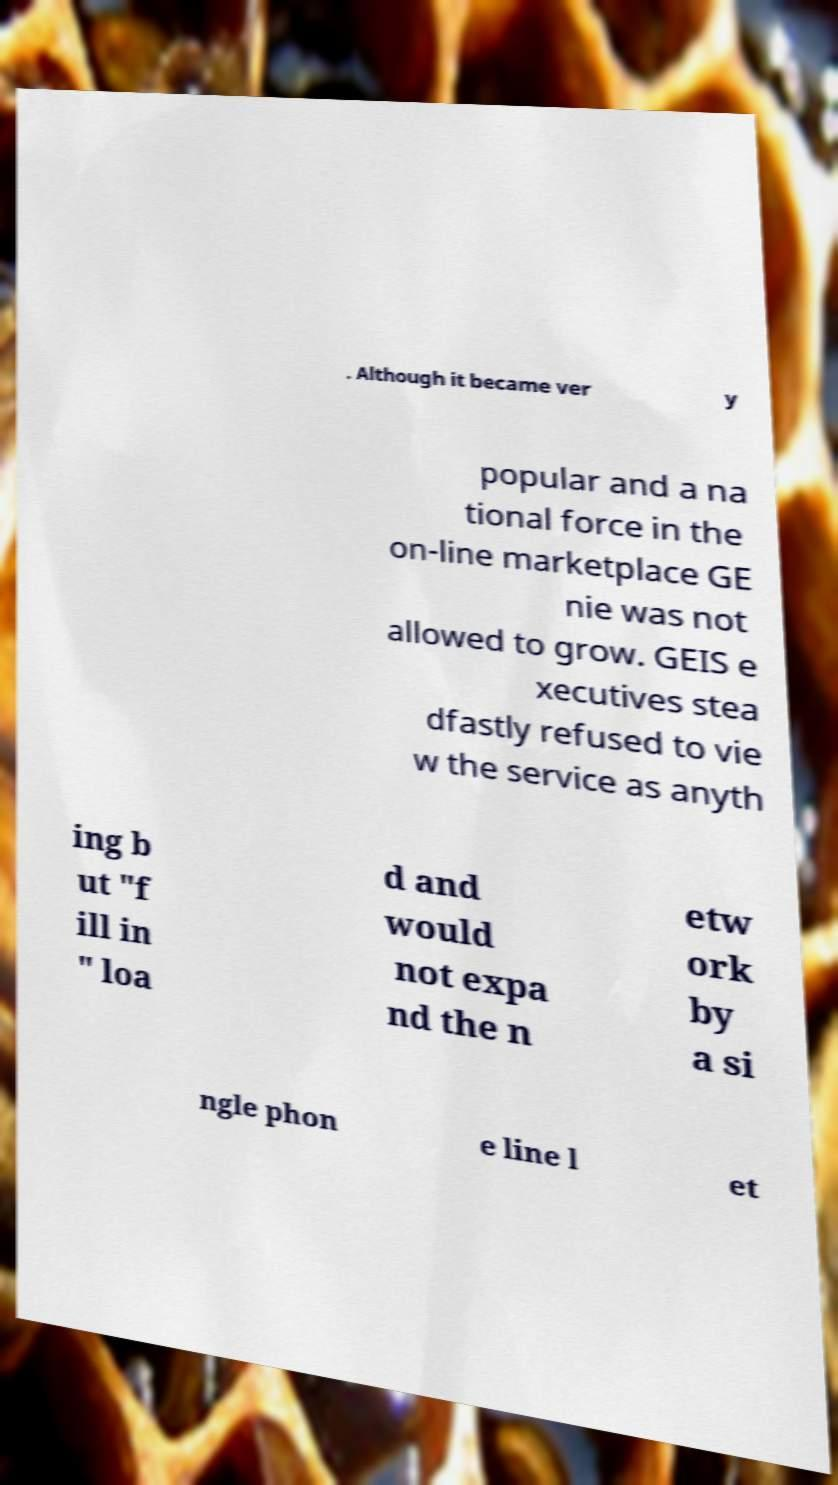Could you extract and type out the text from this image? . Although it became ver y popular and a na tional force in the on-line marketplace GE nie was not allowed to grow. GEIS e xecutives stea dfastly refused to vie w the service as anyth ing b ut "f ill in " loa d and would not expa nd the n etw ork by a si ngle phon e line l et 